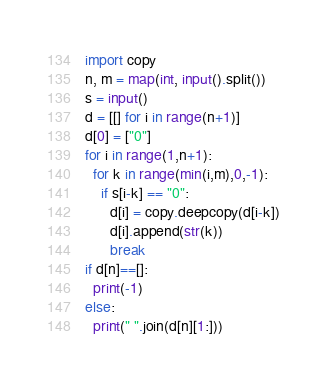<code> <loc_0><loc_0><loc_500><loc_500><_Python_>import copy
n, m = map(int, input().split())
s = input()
d = [[] for i in range(n+1)]
d[0] = ["0"]
for i in range(1,n+1):
  for k in range(min(i,m),0,-1):
    if s[i-k] == "0":
      d[i] = copy.deepcopy(d[i-k])
      d[i].append(str(k))
      break
if d[n]==[]:
  print(-1)
else:
  print(" ".join(d[n][1:]))</code> 